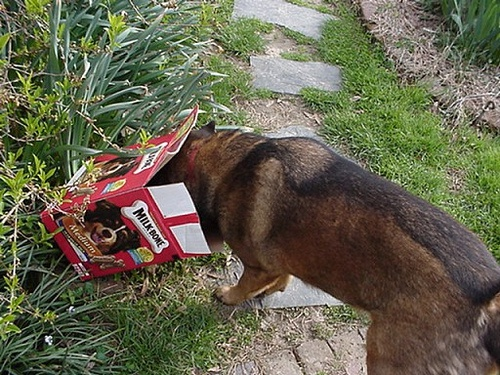Describe the objects in this image and their specific colors. I can see a dog in gray, black, and maroon tones in this image. 